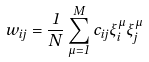<formula> <loc_0><loc_0><loc_500><loc_500>w _ { i j } = \frac { 1 } { N } \sum _ { \mu = 1 } ^ { M } { c _ { i j } \xi ^ { \mu } _ { i } \xi ^ { \mu } _ { j } }</formula> 